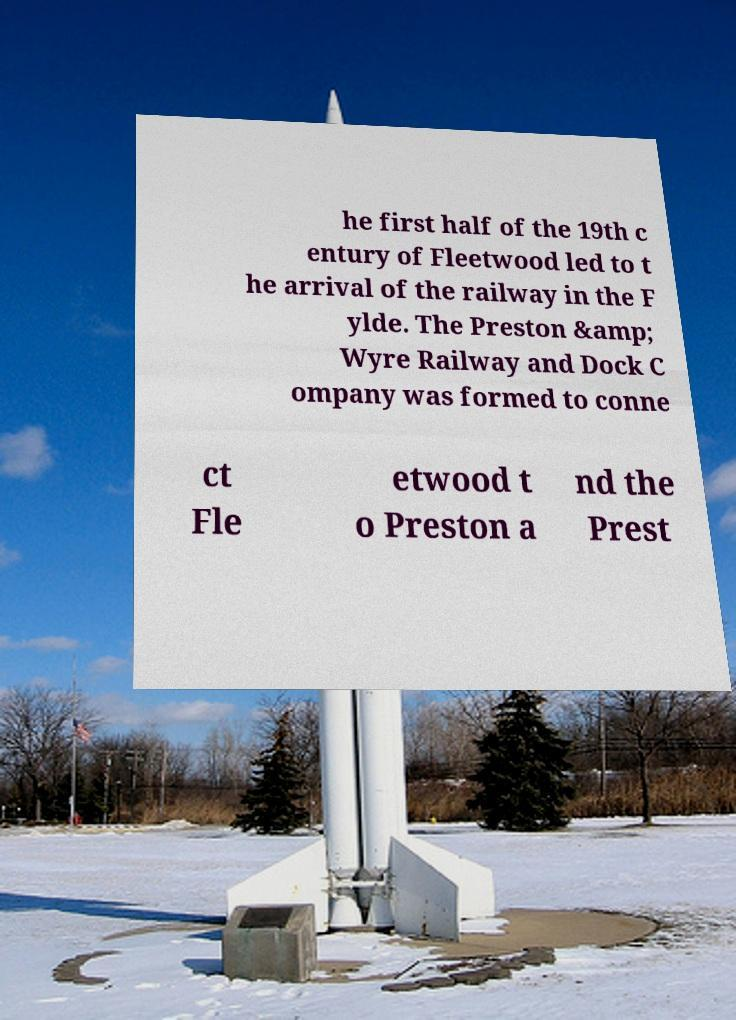For documentation purposes, I need the text within this image transcribed. Could you provide that? he first half of the 19th c entury of Fleetwood led to t he arrival of the railway in the F ylde. The Preston &amp; Wyre Railway and Dock C ompany was formed to conne ct Fle etwood t o Preston a nd the Prest 